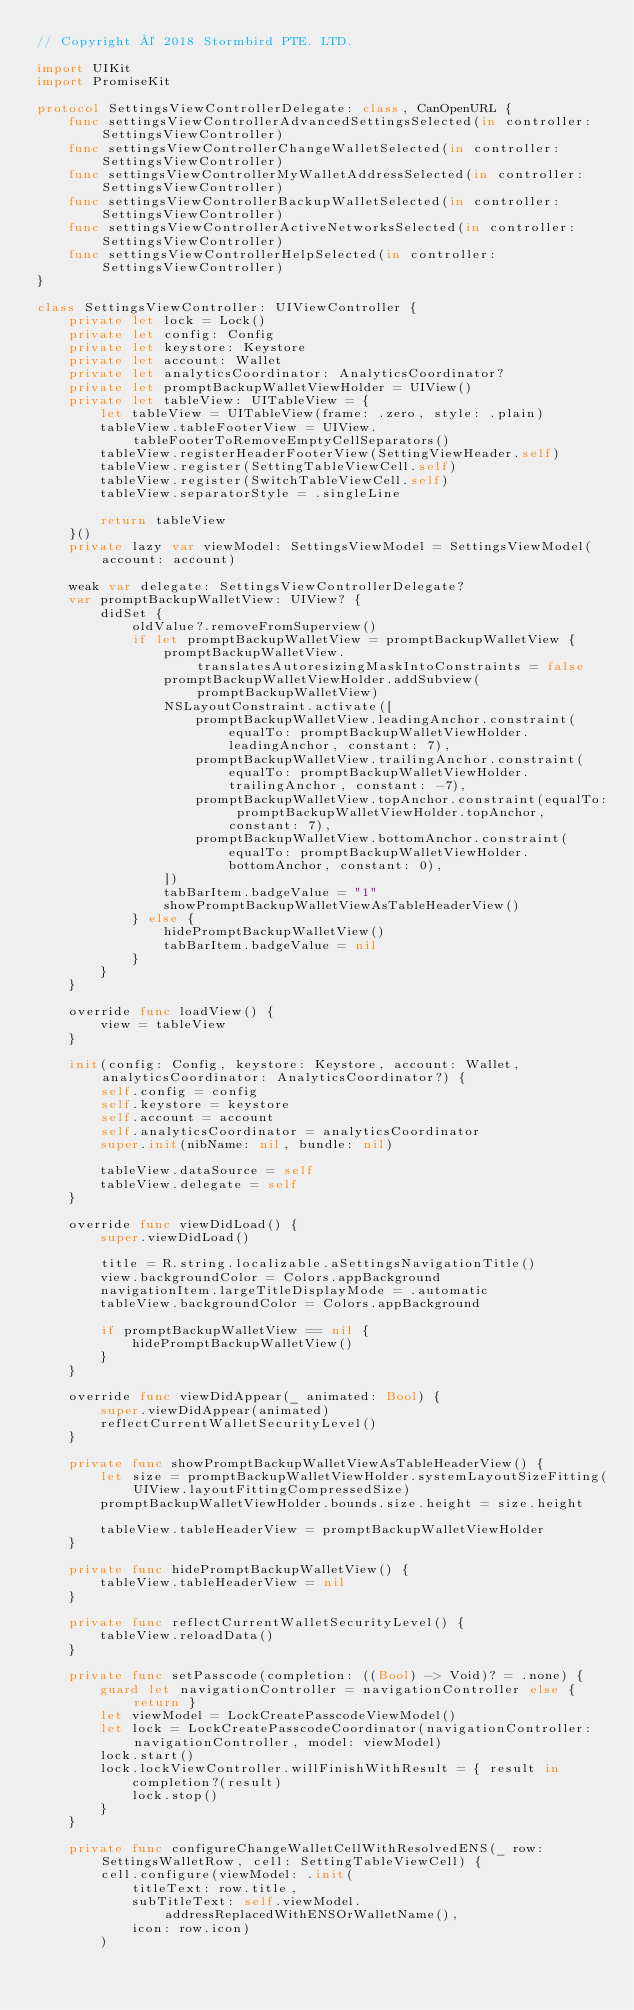Convert code to text. <code><loc_0><loc_0><loc_500><loc_500><_Swift_>// Copyright © 2018 Stormbird PTE. LTD.

import UIKit
import PromiseKit

protocol SettingsViewControllerDelegate: class, CanOpenURL {
    func settingsViewControllerAdvancedSettingsSelected(in controller: SettingsViewController)
    func settingsViewControllerChangeWalletSelected(in controller: SettingsViewController)
    func settingsViewControllerMyWalletAddressSelected(in controller: SettingsViewController)
    func settingsViewControllerBackupWalletSelected(in controller: SettingsViewController)
    func settingsViewControllerActiveNetworksSelected(in controller: SettingsViewController)
    func settingsViewControllerHelpSelected(in controller: SettingsViewController)
}

class SettingsViewController: UIViewController {
    private let lock = Lock()
    private let config: Config
    private let keystore: Keystore
    private let account: Wallet
    private let analyticsCoordinator: AnalyticsCoordinator?
    private let promptBackupWalletViewHolder = UIView()
    private let tableView: UITableView = {
        let tableView = UITableView(frame: .zero, style: .plain)
        tableView.tableFooterView = UIView.tableFooterToRemoveEmptyCellSeparators()
        tableView.registerHeaderFooterView(SettingViewHeader.self)
        tableView.register(SettingTableViewCell.self)
        tableView.register(SwitchTableViewCell.self)
        tableView.separatorStyle = .singleLine

        return tableView
    }()
    private lazy var viewModel: SettingsViewModel = SettingsViewModel(account: account)

    weak var delegate: SettingsViewControllerDelegate?
    var promptBackupWalletView: UIView? {
        didSet {
            oldValue?.removeFromSuperview()
            if let promptBackupWalletView = promptBackupWalletView {
                promptBackupWalletView.translatesAutoresizingMaskIntoConstraints = false
                promptBackupWalletViewHolder.addSubview(promptBackupWalletView)
                NSLayoutConstraint.activate([
                    promptBackupWalletView.leadingAnchor.constraint(equalTo: promptBackupWalletViewHolder.leadingAnchor, constant: 7),
                    promptBackupWalletView.trailingAnchor.constraint(equalTo: promptBackupWalletViewHolder.trailingAnchor, constant: -7),
                    promptBackupWalletView.topAnchor.constraint(equalTo: promptBackupWalletViewHolder.topAnchor, constant: 7),
                    promptBackupWalletView.bottomAnchor.constraint(equalTo: promptBackupWalletViewHolder.bottomAnchor, constant: 0),
                ])
                tabBarItem.badgeValue = "1"
                showPromptBackupWalletViewAsTableHeaderView()
            } else {
                hidePromptBackupWalletView()
                tabBarItem.badgeValue = nil
            }
        }
    }

    override func loadView() {
        view = tableView
    }

    init(config: Config, keystore: Keystore, account: Wallet, analyticsCoordinator: AnalyticsCoordinator?) {
        self.config = config
        self.keystore = keystore
        self.account = account
        self.analyticsCoordinator = analyticsCoordinator
        super.init(nibName: nil, bundle: nil)

        tableView.dataSource = self
        tableView.delegate = self
    }

    override func viewDidLoad() {
        super.viewDidLoad()

        title = R.string.localizable.aSettingsNavigationTitle()
        view.backgroundColor = Colors.appBackground
        navigationItem.largeTitleDisplayMode = .automatic
        tableView.backgroundColor = Colors.appBackground

        if promptBackupWalletView == nil {
            hidePromptBackupWalletView()
        }
    }

    override func viewDidAppear(_ animated: Bool) {
        super.viewDidAppear(animated)
        reflectCurrentWalletSecurityLevel()
    }

    private func showPromptBackupWalletViewAsTableHeaderView() {
        let size = promptBackupWalletViewHolder.systemLayoutSizeFitting(UIView.layoutFittingCompressedSize)
        promptBackupWalletViewHolder.bounds.size.height = size.height

        tableView.tableHeaderView = promptBackupWalletViewHolder
    }

    private func hidePromptBackupWalletView() {
        tableView.tableHeaderView = nil
    }

    private func reflectCurrentWalletSecurityLevel() {
        tableView.reloadData()
    }

    private func setPasscode(completion: ((Bool) -> Void)? = .none) {
        guard let navigationController = navigationController else { return }
        let viewModel = LockCreatePasscodeViewModel()
        let lock = LockCreatePasscodeCoordinator(navigationController: navigationController, model: viewModel)
        lock.start()
        lock.lockViewController.willFinishWithResult = { result in
            completion?(result)
            lock.stop()
        }
    }

    private func configureChangeWalletCellWithResolvedENS(_ row: SettingsWalletRow, cell: SettingTableViewCell) {
        cell.configure(viewModel: .init(
            titleText: row.title,
            subTitleText: self.viewModel.addressReplacedWithENSOrWalletName(),
            icon: row.icon)
        )
</code> 